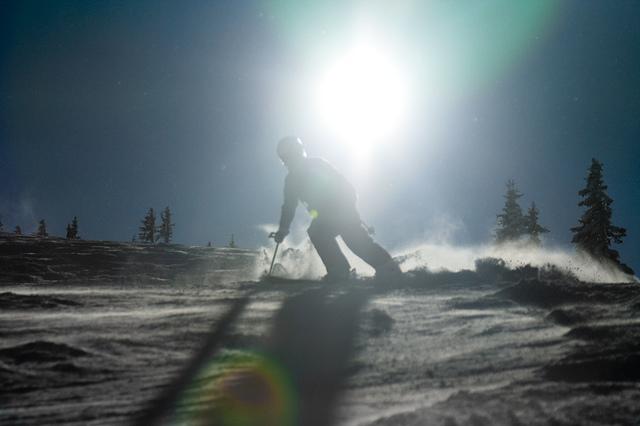Is this a clear photo of the skier?
Give a very brief answer. No. Is the man skiing at night?
Concise answer only. No. Is it dark?
Concise answer only. No. Is there fire in the picture?
Write a very short answer. No. Is the person standing still?
Quick response, please. No. What color is the photo?
Concise answer only. Blue. Are the trees in the background first?
Give a very brief answer. Yes. 